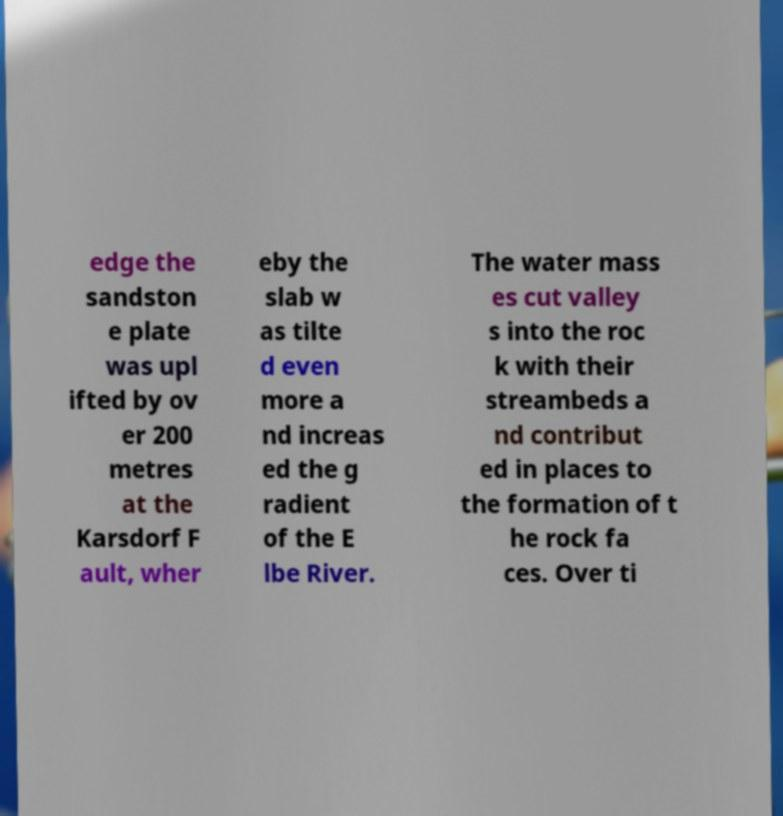Please identify and transcribe the text found in this image. edge the sandston e plate was upl ifted by ov er 200 metres at the Karsdorf F ault, wher eby the slab w as tilte d even more a nd increas ed the g radient of the E lbe River. The water mass es cut valley s into the roc k with their streambeds a nd contribut ed in places to the formation of t he rock fa ces. Over ti 